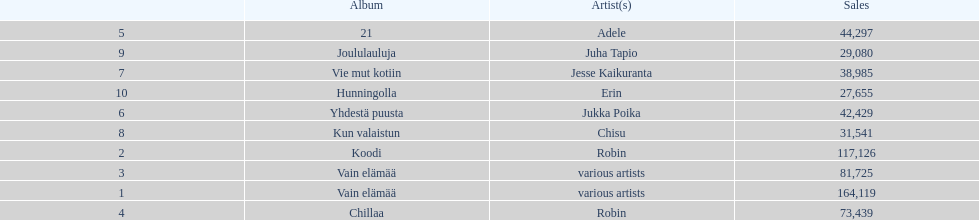What album is listed before 21? Chillaa. 